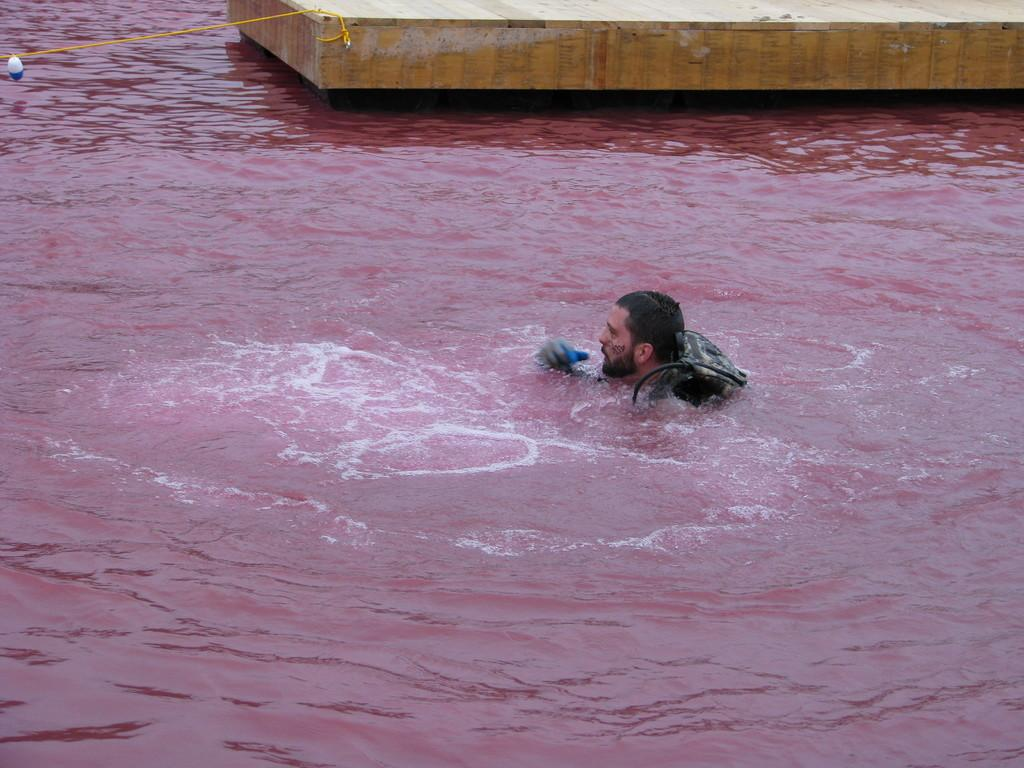What is present in the image? There is water and a person in the water. What is the person wearing in the image? The person is wearing a bag. How does the person use the straw in the image? There is no straw present in the image. 